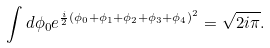Convert formula to latex. <formula><loc_0><loc_0><loc_500><loc_500>\int d \phi _ { 0 } e ^ { \frac { i } { 2 } ( \phi _ { 0 } + \phi _ { 1 } + \phi _ { 2 } + \phi _ { 3 } + \phi _ { 4 } ) ^ { 2 } } = \sqrt { 2 i \pi } .</formula> 